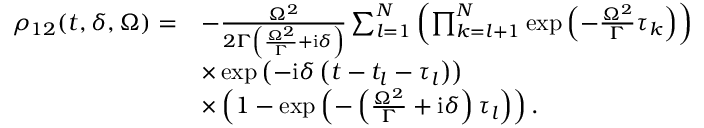Convert formula to latex. <formula><loc_0><loc_0><loc_500><loc_500>\begin{array} { r l } { \rho _ { 1 2 } ( t , \delta , \Omega ) = } & { - \frac { \Omega ^ { 2 } } { 2 \Gamma \left ( \frac { \Omega ^ { 2 } } { \Gamma } + i \delta \right ) } \sum _ { l = 1 } ^ { N } \left ( \prod _ { k = l + 1 } ^ { N } \exp \left ( - \frac { \Omega ^ { 2 } } { \Gamma } \tau _ { k } \right ) \right ) } \\ & { \times \exp \left ( - i \delta \left ( t - t _ { l } - \tau _ { l } \right ) \right ) } \\ & { \times \left ( 1 - \exp \left ( - \left ( \frac { \Omega ^ { 2 } } { \Gamma } + i \delta \right ) \tau _ { l } \right ) \right ) . } \end{array}</formula> 